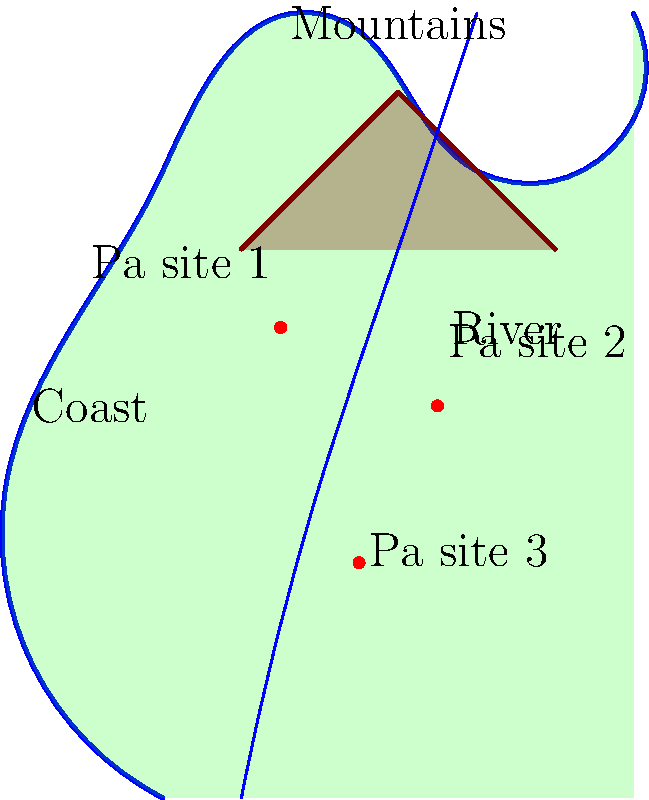Based on the map of Maori pa sites around Timaru, which geographical feature appears to have the strongest influence on the placement of these sites, and why might this be significant from a historical perspective? To answer this question, we need to analyze the spatial relationships between the pa sites and the geographical features shown on the map:

1. Coast: All pa sites are situated inland, away from the immediate coastline.
2. Mountains: The pa sites are positioned below the mountain range, but not directly on it.
3. River: The pa sites form a rough line that follows the course of the river.

Step-by-step analysis:
1. The coast doesn't seem to be the primary influencing factor, as the pa sites are not directly on the coast.
2. The mountains may provide some defensive advantage, but the sites are not positioned on the mountains themselves.
3. The river appears to have the strongest correlation with pa site placement:
   a. All three sites are in close proximity to the river.
   b. The sites form a line that roughly follows the river's course.
   c. This pattern suggests that the river was a crucial factor in site selection.

Historical significance:
1. Rivers were essential for Maori settlements as they provided:
   a. Fresh water for drinking and agriculture
   b. Transportation routes
   c. Access to food resources (fish, eels, etc.)
2. The placement near, but not directly on, the river suggests a balance between:
   a. Easy access to water resources
   b. Protection from flooding
   c. Possible defensive advantages (higher ground)
3. This river-oriented placement strategy indicates the importance of water management and resource access in Maori settlement patterns around Timaru.
Answer: The river, due to its importance for water, transportation, and food resources in Maori settlements. 